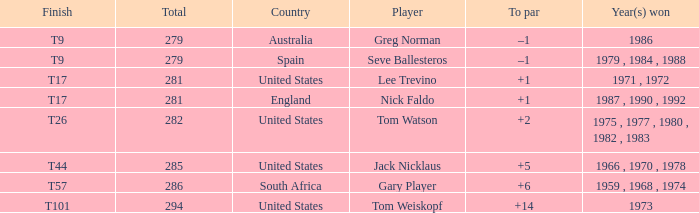Which player is from Australia? Greg Norman. 